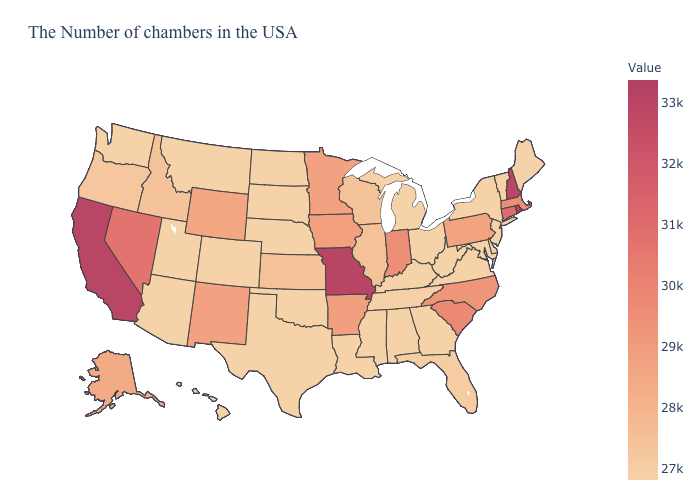Among the states that border Maryland , which have the highest value?
Concise answer only. Pennsylvania. Among the states that border New York , does Connecticut have the highest value?
Answer briefly. Yes. Among the states that border South Dakota , which have the highest value?
Quick response, please. Iowa. Which states have the lowest value in the USA?
Keep it brief. Maine, Vermont, New York, New Jersey, Delaware, Maryland, Virginia, West Virginia, Ohio, Georgia, Michigan, Kentucky, Alabama, Mississippi, Louisiana, Nebraska, Oklahoma, Texas, South Dakota, North Dakota, Colorado, Utah, Montana, Arizona, Washington, Hawaii. Among the states that border Montana , which have the highest value?
Quick response, please. Wyoming. 